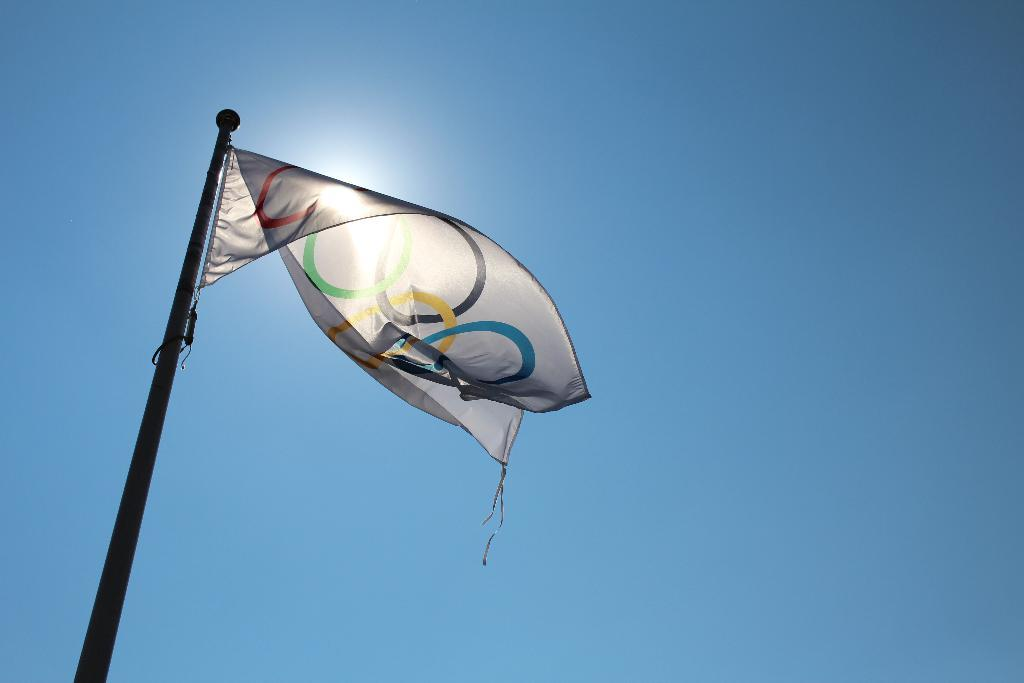What object is present in the image that represents a country or organization? There is a flag in the image. How is the flag positioned in the image? The flag is on a pole. What can be seen in the background of the image? The sky is visible in the background of the image. What type of polish is being applied to the flag in the image? There is no indication in the image that any polish is being applied to the flag. 